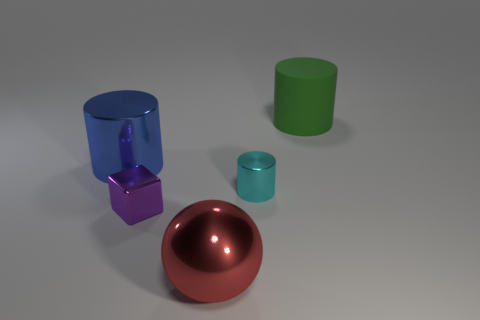Subtract all big cylinders. How many cylinders are left? 1 Subtract 1 cylinders. How many cylinders are left? 2 Add 3 brown cylinders. How many objects exist? 8 Subtract all balls. How many objects are left? 4 Add 3 small shiny blocks. How many small shiny blocks are left? 4 Add 4 small red shiny cylinders. How many small red shiny cylinders exist? 4 Subtract 0 blue balls. How many objects are left? 5 Subtract all blue matte spheres. Subtract all purple metallic things. How many objects are left? 4 